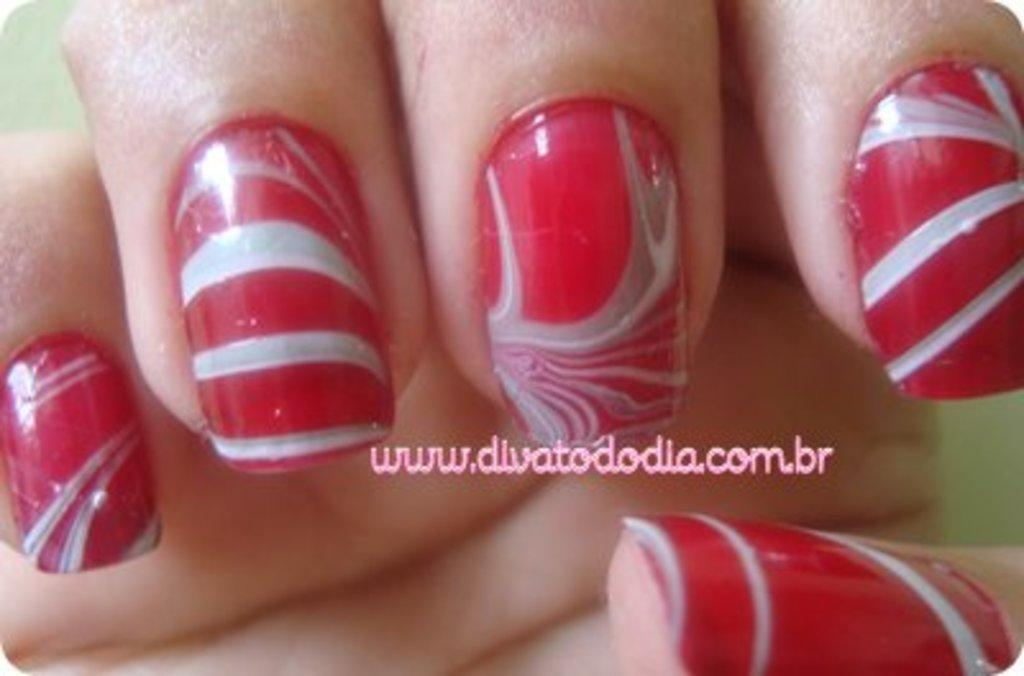<image>
Offer a succinct explanation of the picture presented. Red and white swirled nails are used to advertise www.divatododia.com.br. 